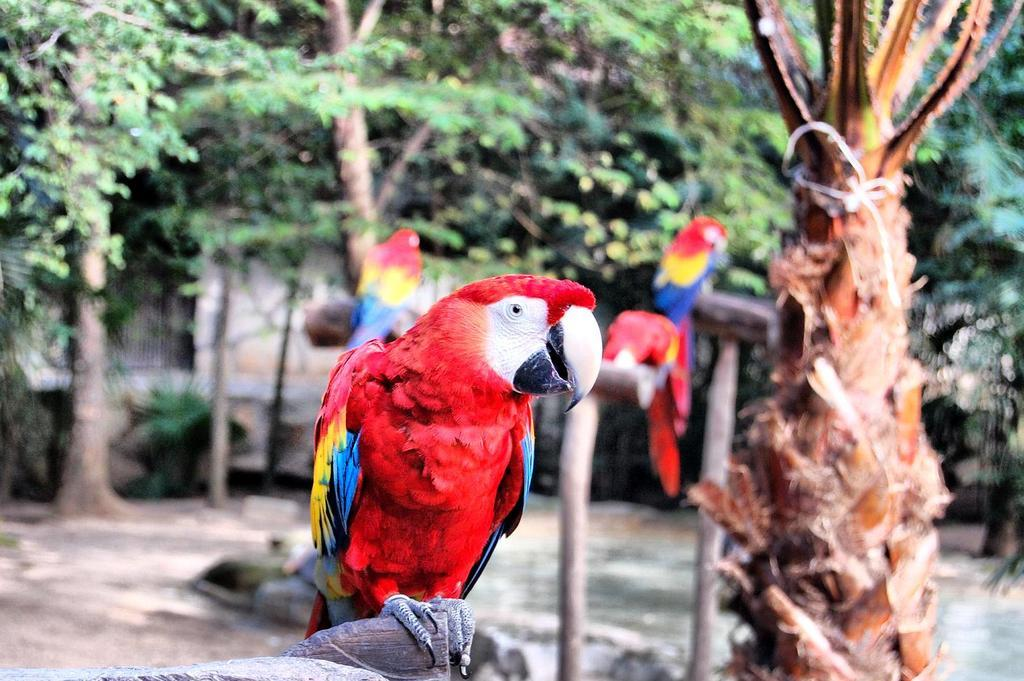What type of animals can be seen in the image? There are birds in the image. What colors are present on the birds? The birds have red, yellow, and blue colors. What can be seen in the background of the image? There are trees in the background of the image. What color are the trees? The trees have a green color. What type of zipper can be seen on the bird's wing in the image? There is no zipper present on the bird's wing in the image. 